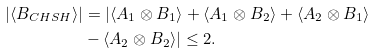<formula> <loc_0><loc_0><loc_500><loc_500>| \langle B _ { C H S H } \rangle | & = | \langle A _ { 1 } \otimes B _ { 1 } \rangle + \langle A _ { 1 } \otimes B _ { 2 } \rangle + \langle A _ { 2 } \otimes B _ { 1 } \rangle \\ & - \langle A _ { 2 } \otimes B _ { 2 } \rangle | \leq 2 .</formula> 